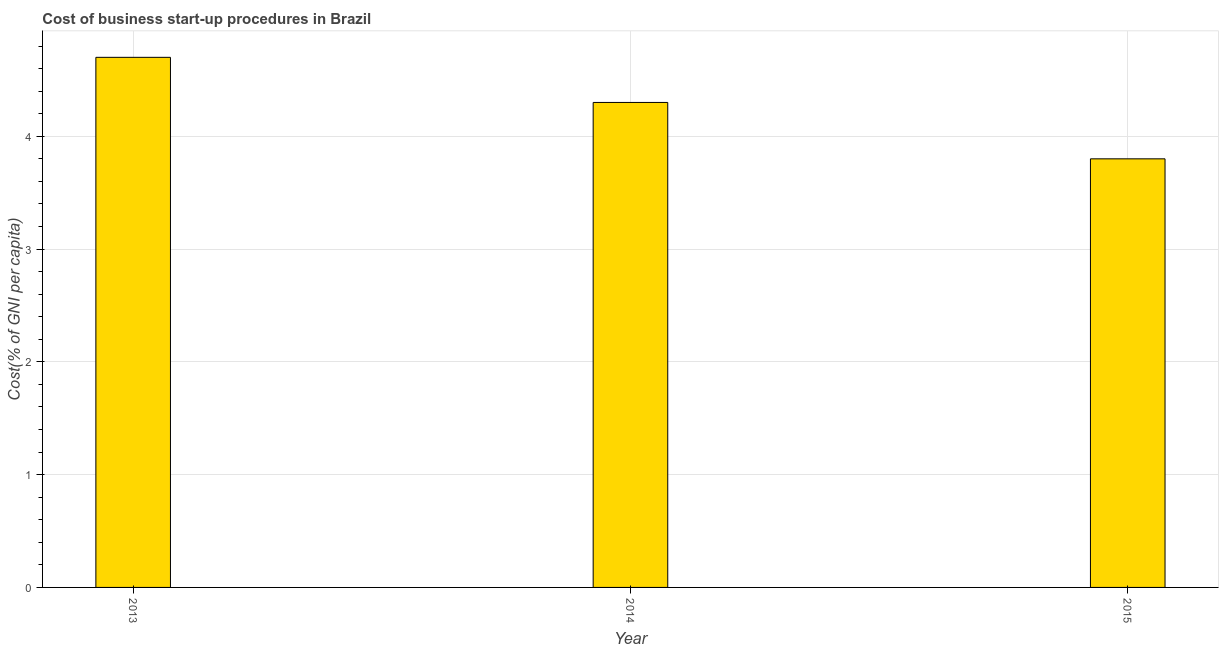Does the graph contain grids?
Provide a short and direct response. Yes. What is the title of the graph?
Provide a succinct answer. Cost of business start-up procedures in Brazil. What is the label or title of the Y-axis?
Your response must be concise. Cost(% of GNI per capita). Across all years, what is the maximum cost of business startup procedures?
Make the answer very short. 4.7. Across all years, what is the minimum cost of business startup procedures?
Give a very brief answer. 3.8. In which year was the cost of business startup procedures maximum?
Your answer should be compact. 2013. In which year was the cost of business startup procedures minimum?
Keep it short and to the point. 2015. What is the average cost of business startup procedures per year?
Provide a succinct answer. 4.27. In how many years, is the cost of business startup procedures greater than 3.4 %?
Make the answer very short. 3. What is the ratio of the cost of business startup procedures in 2013 to that in 2015?
Ensure brevity in your answer.  1.24. Is the sum of the cost of business startup procedures in 2013 and 2014 greater than the maximum cost of business startup procedures across all years?
Make the answer very short. Yes. What is the difference between the highest and the lowest cost of business startup procedures?
Provide a short and direct response. 0.9. Are all the bars in the graph horizontal?
Your answer should be compact. No. Are the values on the major ticks of Y-axis written in scientific E-notation?
Your answer should be compact. No. What is the Cost(% of GNI per capita) of 2013?
Your answer should be compact. 4.7. What is the Cost(% of GNI per capita) of 2014?
Make the answer very short. 4.3. What is the Cost(% of GNI per capita) in 2015?
Offer a terse response. 3.8. What is the difference between the Cost(% of GNI per capita) in 2013 and 2014?
Your answer should be compact. 0.4. What is the difference between the Cost(% of GNI per capita) in 2014 and 2015?
Offer a very short reply. 0.5. What is the ratio of the Cost(% of GNI per capita) in 2013 to that in 2014?
Ensure brevity in your answer.  1.09. What is the ratio of the Cost(% of GNI per capita) in 2013 to that in 2015?
Offer a terse response. 1.24. What is the ratio of the Cost(% of GNI per capita) in 2014 to that in 2015?
Make the answer very short. 1.13. 